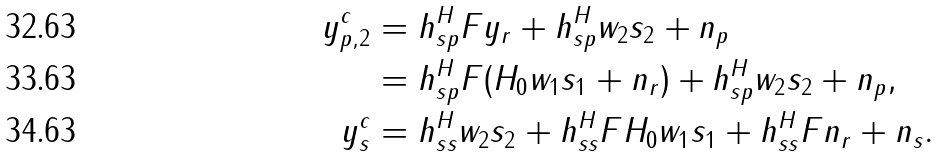<formula> <loc_0><loc_0><loc_500><loc_500>y _ { p , 2 } ^ { c } & = h _ { s p } ^ { H } F y _ { r } + h _ { s p } ^ { H } w _ { 2 } { s } _ { 2 } + n _ { p } \\ & = h _ { s p } ^ { H } F ( H _ { 0 } w _ { 1 } { s } _ { 1 } + n _ { r } ) + h _ { s p } ^ { H } w _ { 2 } { s } _ { 2 } + n _ { p } , \\ y _ { s } ^ { c } & = h _ { s s } ^ { H } w _ { 2 } { s } _ { 2 } + h _ { s s } ^ { H } F H _ { 0 } w _ { 1 } { s } _ { 1 } + h _ { s s } ^ { H } F n _ { r } + n _ { s } .</formula> 